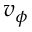<formula> <loc_0><loc_0><loc_500><loc_500>v _ { \phi }</formula> 